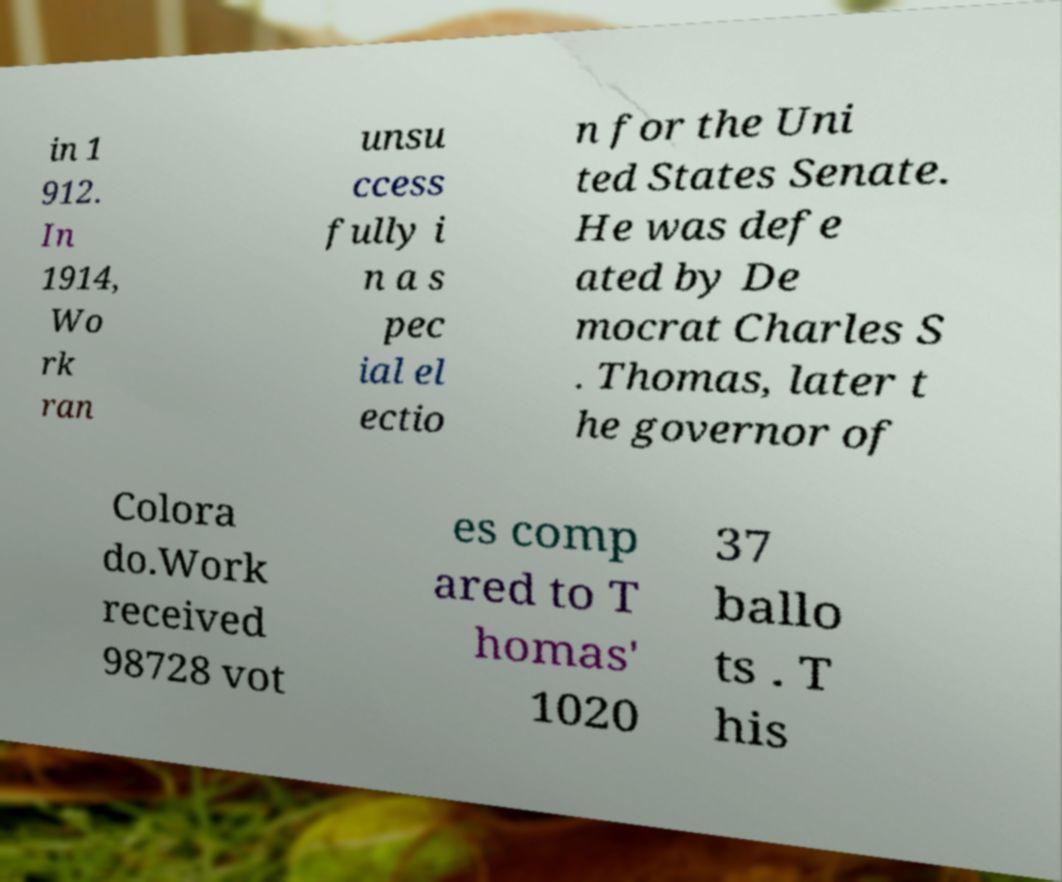I need the written content from this picture converted into text. Can you do that? in 1 912. In 1914, Wo rk ran unsu ccess fully i n a s pec ial el ectio n for the Uni ted States Senate. He was defe ated by De mocrat Charles S . Thomas, later t he governor of Colora do.Work received 98728 vot es comp ared to T homas' 1020 37 ballo ts . T his 